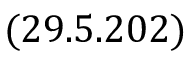Convert formula to latex. <formula><loc_0><loc_0><loc_500><loc_500>( 2 9 . 5 . 2 0 2 )</formula> 